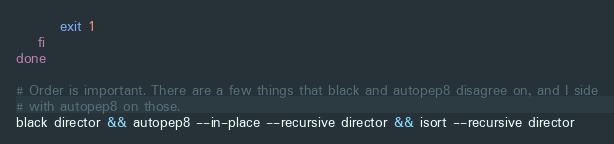Convert code to text. <code><loc_0><loc_0><loc_500><loc_500><_Bash_>        exit 1
    fi
done

# Order is important. There are a few things that black and autopep8 disagree on, and I side
# with autopep8 on those.
black director && autopep8 --in-place --recursive director && isort --recursive director
</code> 